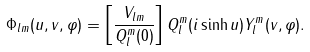Convert formula to latex. <formula><loc_0><loc_0><loc_500><loc_500>\Phi _ { l m } ( u , v , \varphi ) = \left [ \frac { V _ { l m } } { Q _ { l } ^ { m } ( 0 ) } \right ] Q _ { l } ^ { m } ( i \sinh u ) Y _ { l } ^ { m } ( v , \varphi ) .</formula> 